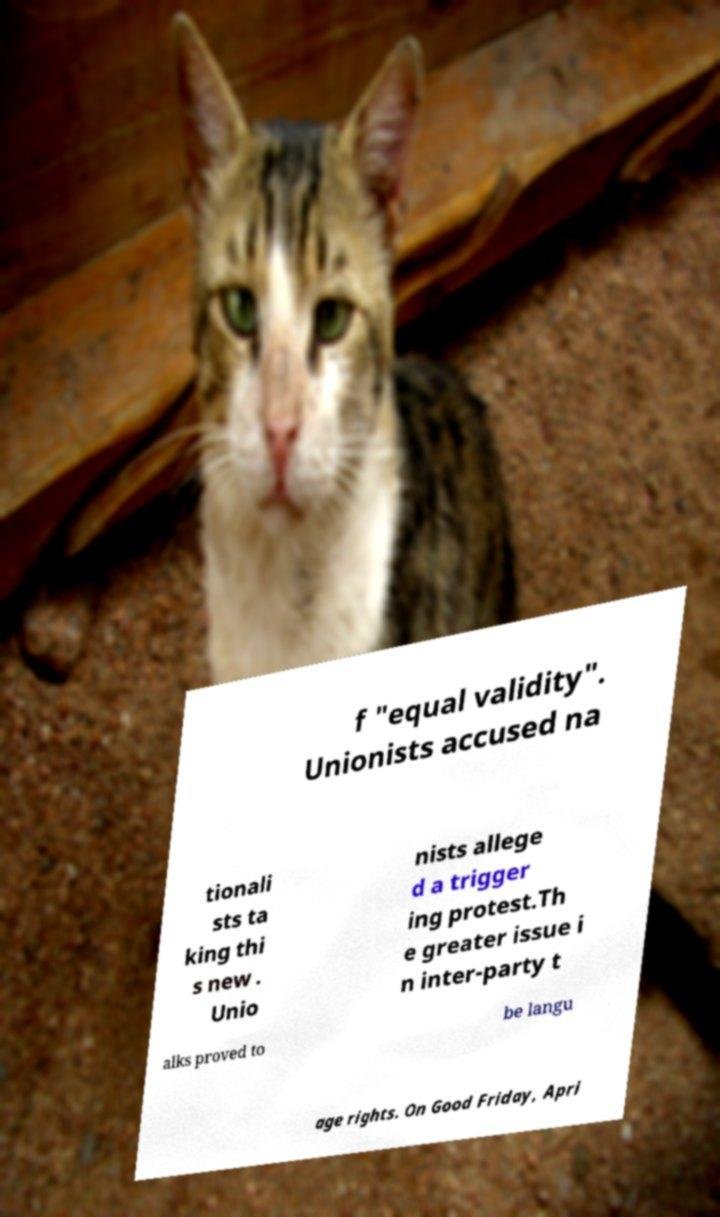Can you accurately transcribe the text from the provided image for me? f "equal validity". Unionists accused na tionali sts ta king thi s new . Unio nists allege d a trigger ing protest.Th e greater issue i n inter-party t alks proved to be langu age rights. On Good Friday, Apri 